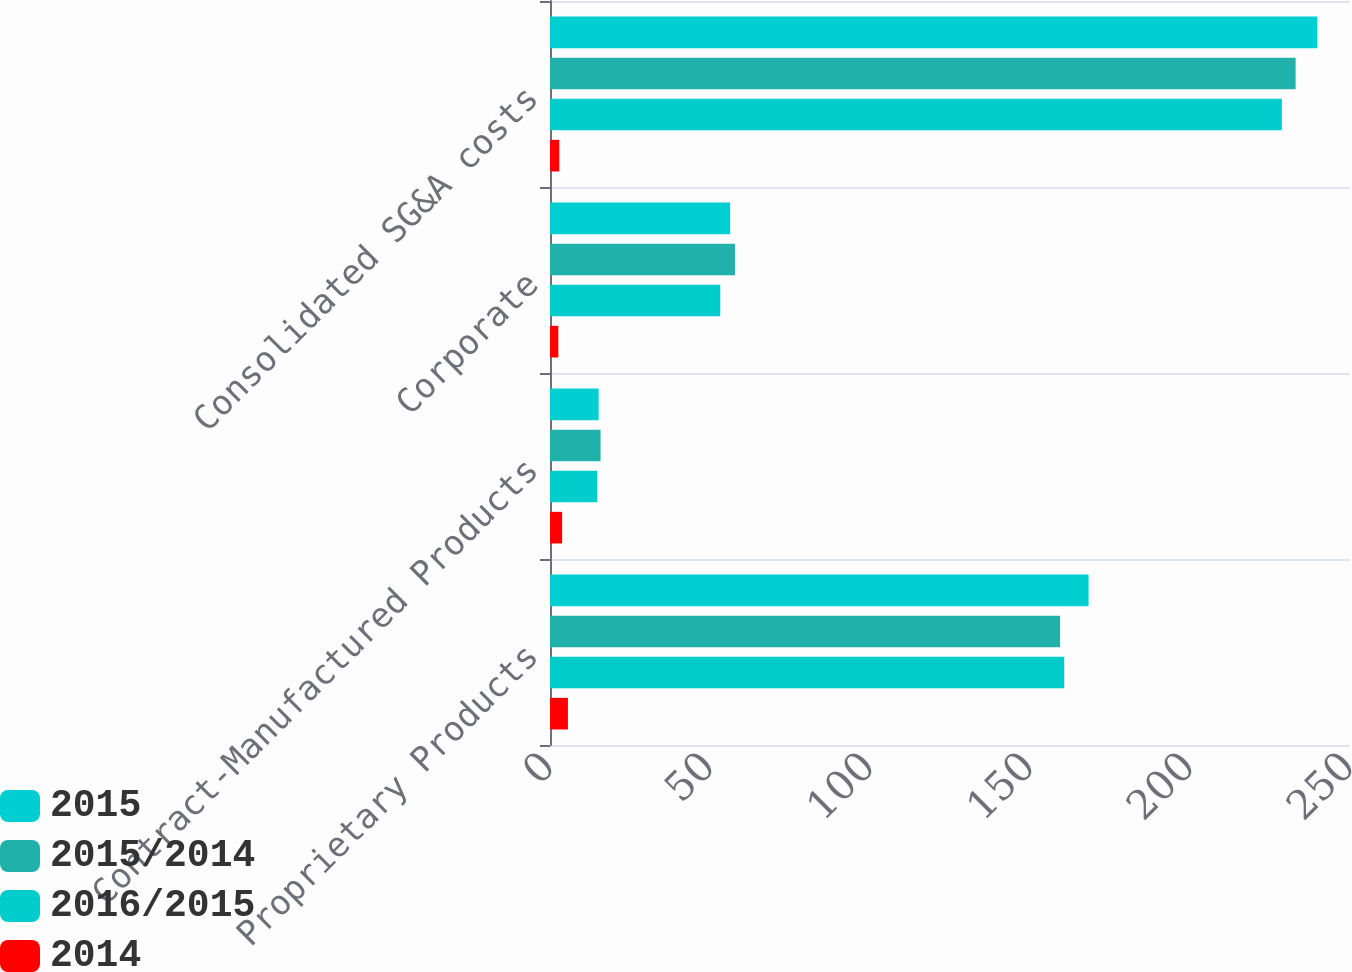Convert chart. <chart><loc_0><loc_0><loc_500><loc_500><stacked_bar_chart><ecel><fcel>Proprietary Products<fcel>Contract-Manufactured Products<fcel>Corporate<fcel>Consolidated SG&A costs<nl><fcel>2015<fcel>168.3<fcel>15.2<fcel>56.3<fcel>239.8<nl><fcel>2015/2014<fcel>159.4<fcel>15.8<fcel>57.8<fcel>233<nl><fcel>2016/2015<fcel>160.7<fcel>14.8<fcel>53.2<fcel>228.7<nl><fcel>2014<fcel>5.6<fcel>3.8<fcel>2.6<fcel>2.9<nl></chart> 